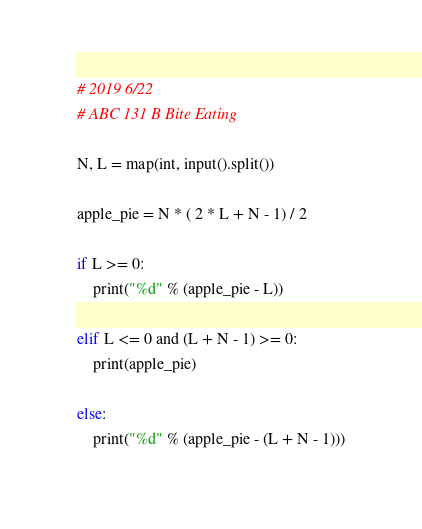Convert code to text. <code><loc_0><loc_0><loc_500><loc_500><_Python_># 2019 6/22
# ABC 131 B Bite Eating

N, L = map(int, input().split())

apple_pie = N * ( 2 * L + N - 1) / 2

if L >= 0:
    print("%d" % (apple_pie - L))

elif L <= 0 and (L + N - 1) >= 0:
    print(apple_pie)

else:
    print("%d" % (apple_pie - (L + N - 1)))</code> 